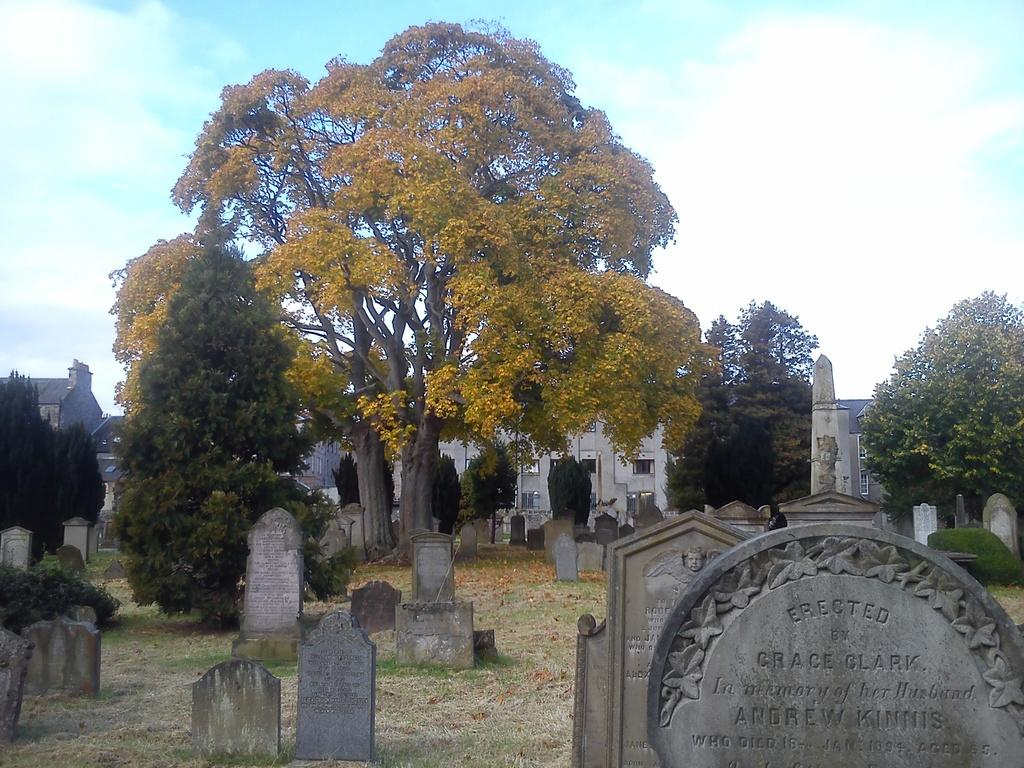What type of natural elements can be seen in the image? There are trees in the image. What is located on the ground in the image? There is a graveyard on the ground in the image. What can be seen in the distance in the image? There are buildings visible in the background of the image. What part of the natural environment is visible in the image? The sky is visible in the background of the image. What type of government is responsible for the sidewalk in the image? There is no sidewalk present in the image, so it is not possible to determine which government might be responsible for it. 